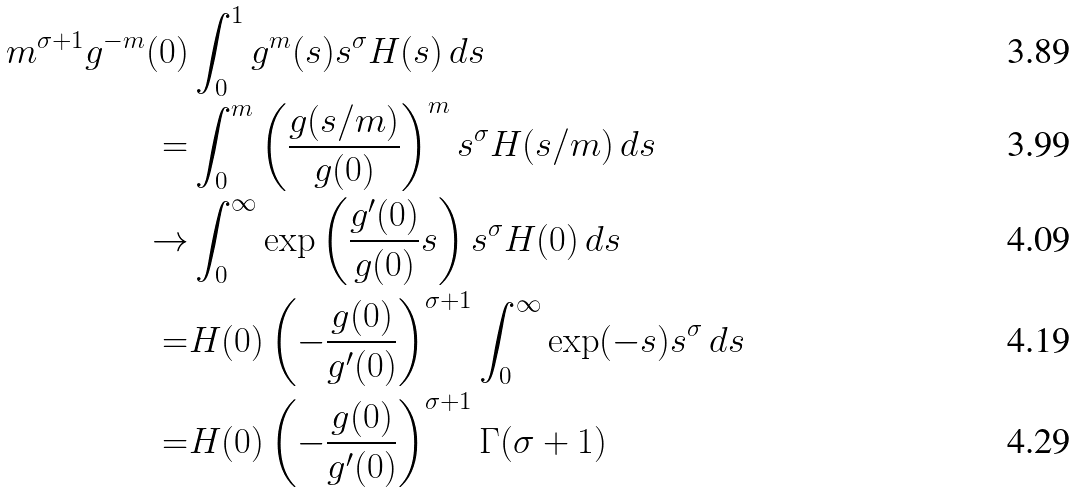<formula> <loc_0><loc_0><loc_500><loc_500>m ^ { \sigma + 1 } g ^ { - m } ( 0 ) & \int _ { 0 } ^ { 1 } g ^ { m } ( s ) s ^ { \sigma } H ( s ) \, d s \\ = & \int _ { 0 } ^ { m } \left ( \frac { g ( s / m ) } { g ( 0 ) } \right ) ^ { m } s ^ { \sigma } H ( s / m ) \, d s \\ \to & \int _ { 0 } ^ { \infty } \exp \left ( \frac { g ^ { \prime } ( 0 ) } { g ( 0 ) } s \right ) s ^ { \sigma } H ( 0 ) \, d s \\ = & H ( 0 ) \left ( - \frac { g ( 0 ) } { g ^ { \prime } ( 0 ) } \right ) ^ { \sigma + 1 } \int _ { 0 } ^ { \infty } \exp ( - s ) s ^ { \sigma } \, d s \\ = & H ( 0 ) \left ( - \frac { g ( 0 ) } { g ^ { \prime } ( 0 ) } \right ) ^ { \sigma + 1 } \Gamma ( \sigma + 1 )</formula> 